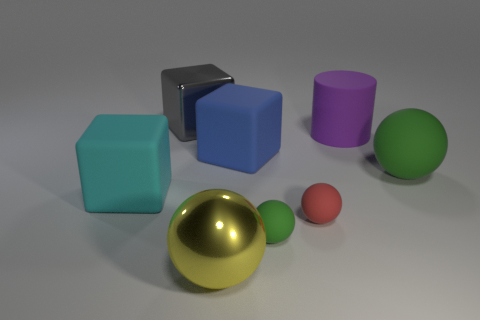Are there any other green things that have the same shape as the big green thing?
Your answer should be compact. Yes. What number of things are either large cubes right of the cyan matte block or small green things?
Give a very brief answer. 3. Is the number of red spheres greater than the number of brown spheres?
Keep it short and to the point. Yes. Are there any rubber cubes of the same size as the yellow shiny sphere?
Your answer should be compact. Yes. How many things are spheres that are on the left side of the tiny red matte sphere or spheres that are on the left side of the large blue matte cube?
Ensure brevity in your answer.  2. There is a matte thing that is on the left side of the large block behind the purple matte cylinder; what color is it?
Provide a succinct answer. Cyan. There is a big ball that is the same material as the large cylinder; what is its color?
Offer a very short reply. Green. What number of tiny matte spheres have the same color as the metal cube?
Offer a terse response. 0. What number of things are big purple things or rubber blocks?
Your answer should be very brief. 3. The yellow metal thing that is the same size as the cyan rubber thing is what shape?
Provide a succinct answer. Sphere. 